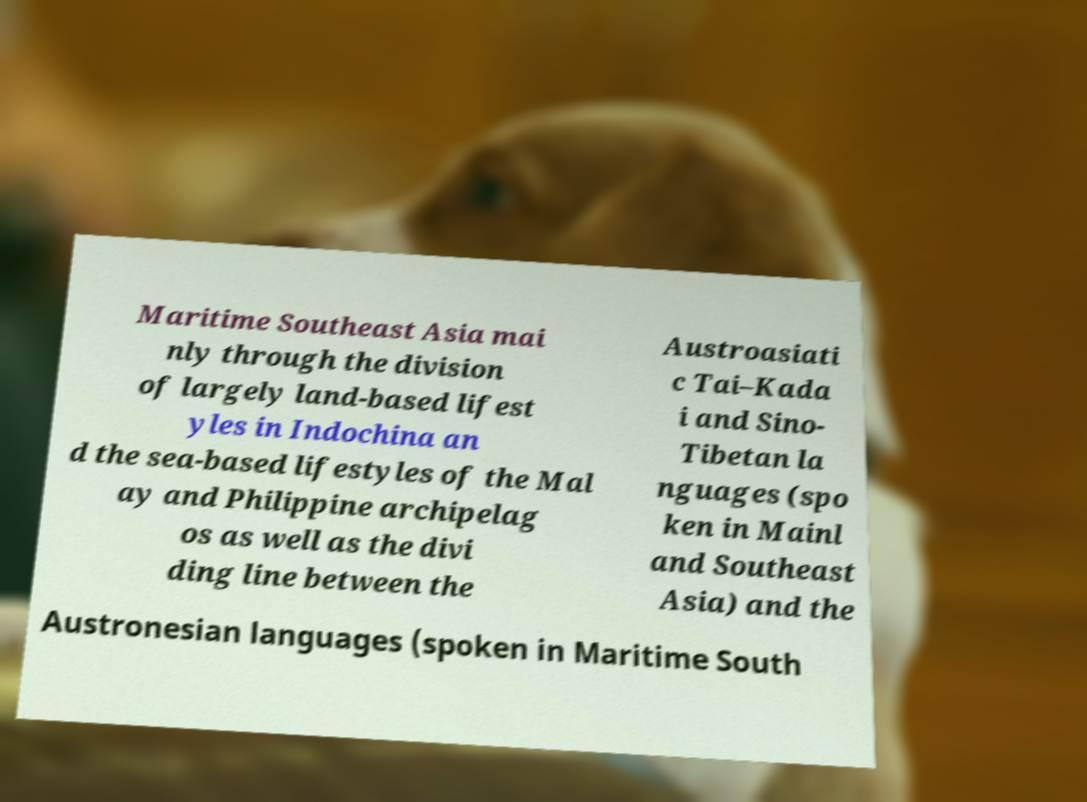Can you accurately transcribe the text from the provided image for me? Maritime Southeast Asia mai nly through the division of largely land-based lifest yles in Indochina an d the sea-based lifestyles of the Mal ay and Philippine archipelag os as well as the divi ding line between the Austroasiati c Tai–Kada i and Sino- Tibetan la nguages (spo ken in Mainl and Southeast Asia) and the Austronesian languages (spoken in Maritime South 